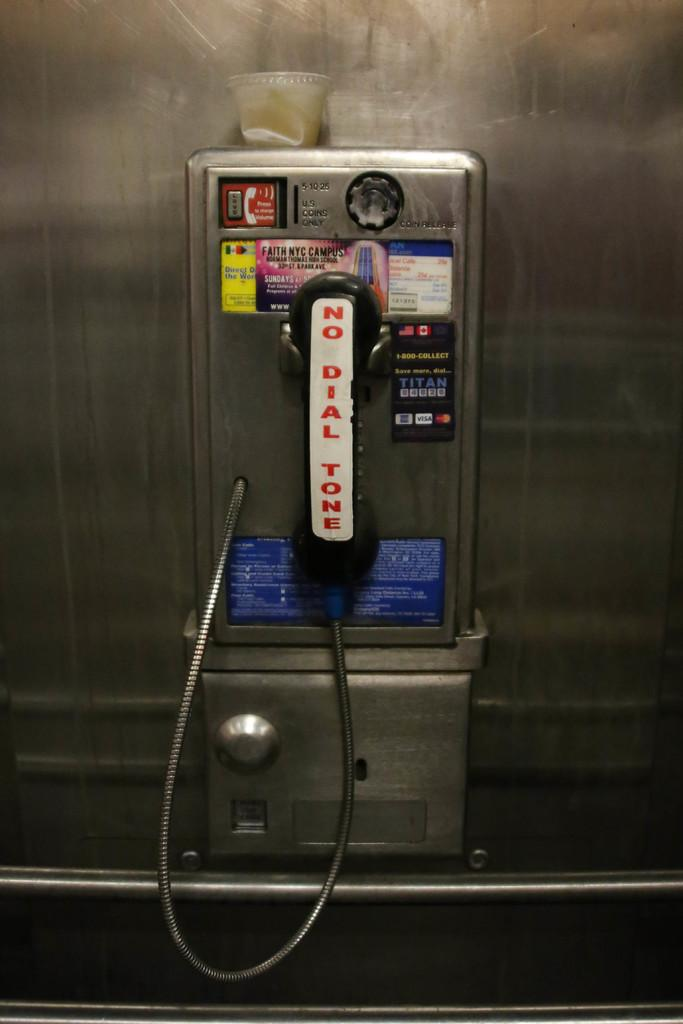What object is the main focus of the image? There is a telephone in the image. Are there any decorations or modifications on the telephone? Yes, the telephone has stickers on it. What is located above the telephone? There is a cup above the telephone. What type of material is used for the rod in the image? There is a steel rod in the image. What is the wall made of in the image? There is a steel wall in the image. What type of elbow can be seen in the image? There is no elbow present in the image; it features a telephone, a cup, a steel rod, and a steel wall. 